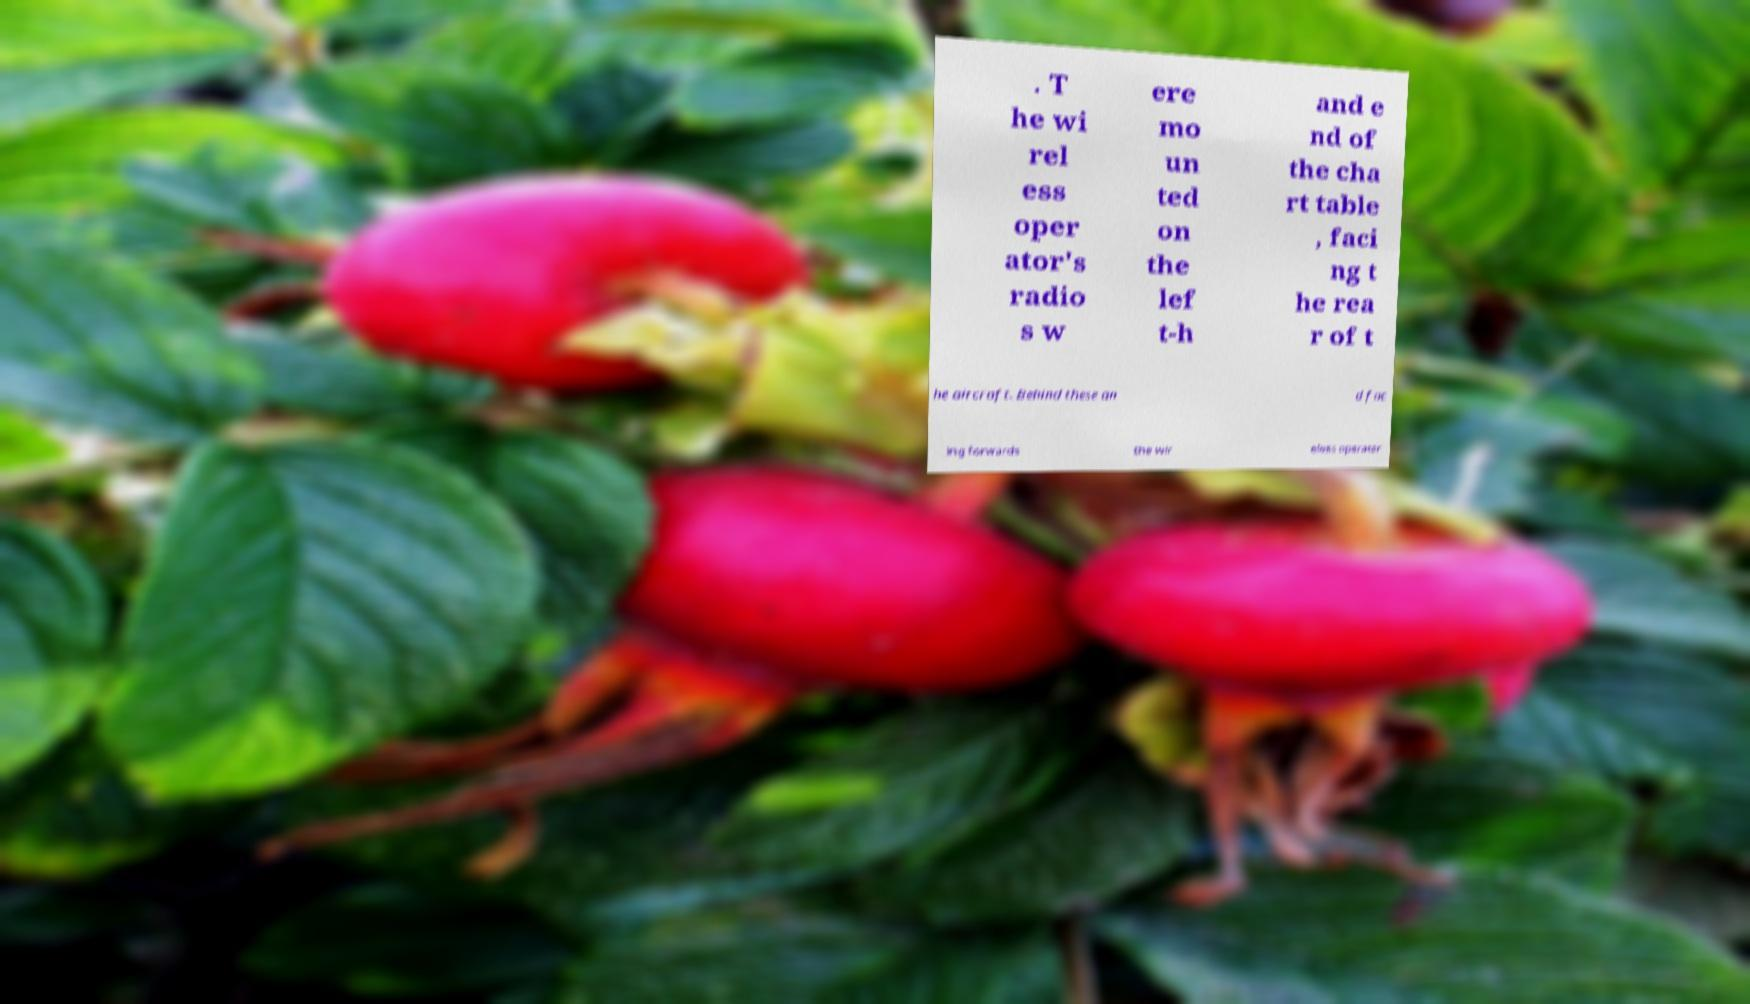Can you read and provide the text displayed in the image?This photo seems to have some interesting text. Can you extract and type it out for me? . T he wi rel ess oper ator's radio s w ere mo un ted on the lef t-h and e nd of the cha rt table , faci ng t he rea r of t he aircraft. Behind these an d fac ing forwards the wir eless operator 